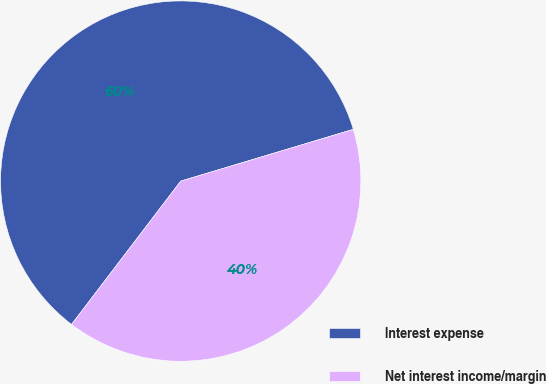Convert chart. <chart><loc_0><loc_0><loc_500><loc_500><pie_chart><fcel>Interest expense<fcel>Net interest income/margin<nl><fcel>60.0%<fcel>40.0%<nl></chart> 